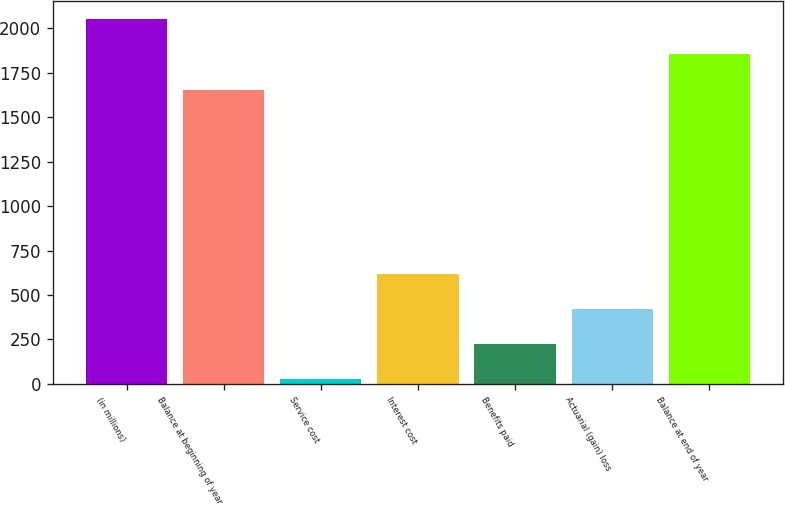Convert chart. <chart><loc_0><loc_0><loc_500><loc_500><bar_chart><fcel>(in millions)<fcel>Balance at beginning of year<fcel>Service cost<fcel>Interest cost<fcel>Benefits paid<fcel>Actuarial (gain) loss<fcel>Balance at end of year<nl><fcel>2050.4<fcel>1655<fcel>27<fcel>620.1<fcel>224.7<fcel>422.4<fcel>1852.7<nl></chart> 